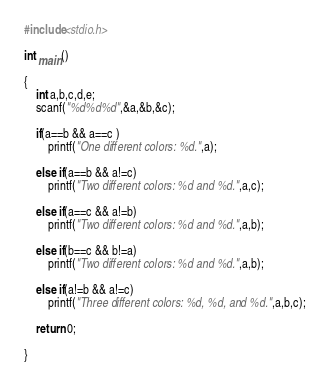Convert code to text. <code><loc_0><loc_0><loc_500><loc_500><_C_>#include<stdio.h>

int main()

{
    int a,b,c,d,e;
    scanf("%d%d%d",&a,&b,&c);

    if(a==b && a==c )
        printf("One different colors: %d.",a);

    else if(a==b && a!=c)
        printf("Two different colors: %d and %d.",a,c);

    else if(a==c && a!=b)
        printf("Two different colors: %d and %d.",a,b);

    else if(b==c && b!=a)
        printf("Two different colors: %d and %d.",a,b);

    else if(a!=b && a!=c)
        printf("Three different colors: %d, %d, and %d.",a,b,c);

    return 0;

}</code> 